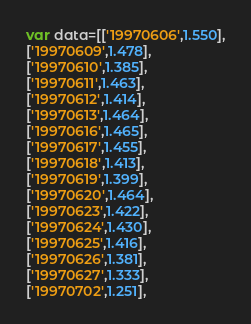Convert code to text. <code><loc_0><loc_0><loc_500><loc_500><_JavaScript_>var data=[['19970606',1.550],
['19970609',1.478],
['19970610',1.385],
['19970611',1.463],
['19970612',1.414],
['19970613',1.464],
['19970616',1.465],
['19970617',1.455],
['19970618',1.413],
['19970619',1.399],
['19970620',1.464],
['19970623',1.422],
['19970624',1.430],
['19970625',1.416],
['19970626',1.381],
['19970627',1.333],
['19970702',1.251],</code> 